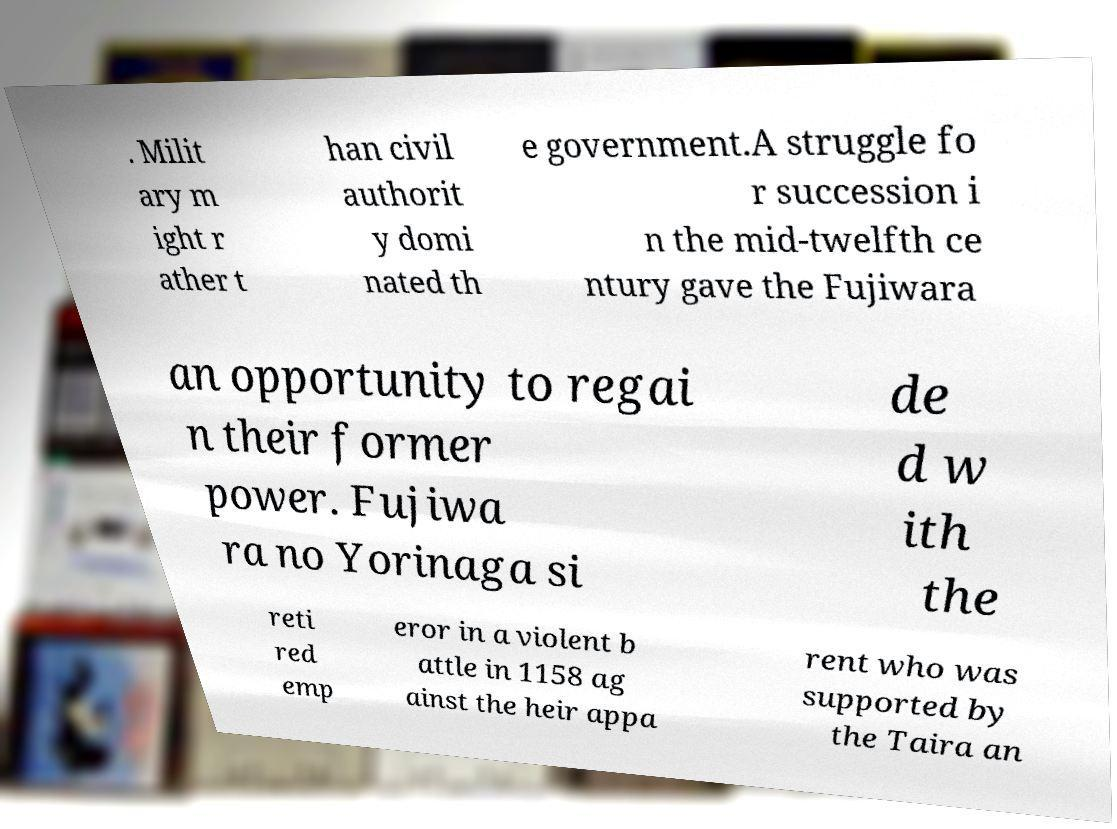Can you accurately transcribe the text from the provided image for me? . Milit ary m ight r ather t han civil authorit y domi nated th e government.A struggle fo r succession i n the mid-twelfth ce ntury gave the Fujiwara an opportunity to regai n their former power. Fujiwa ra no Yorinaga si de d w ith the reti red emp eror in a violent b attle in 1158 ag ainst the heir appa rent who was supported by the Taira an 